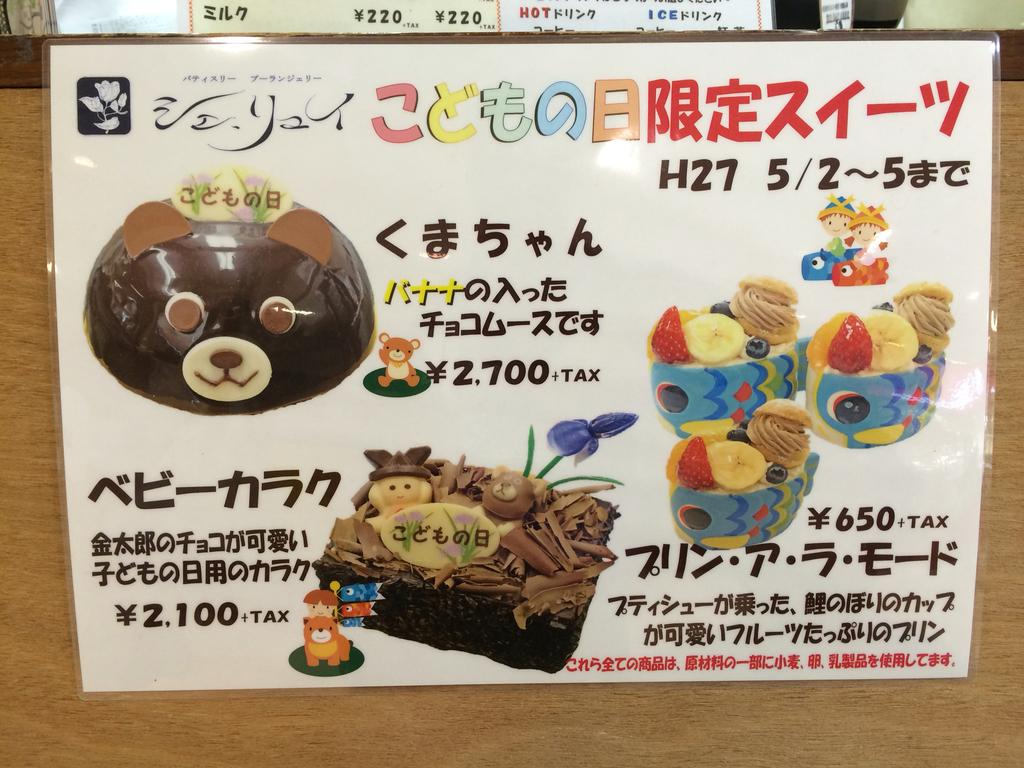What is on the board in the image? There is a sticker on a board in the image. What is depicted on the sticker? The sticker contains different kinds of cake. What color is the sweater worn by the cake in the image? There is no sweater worn by the cake in the image, as the sticker only contains images of different kinds of cake. 